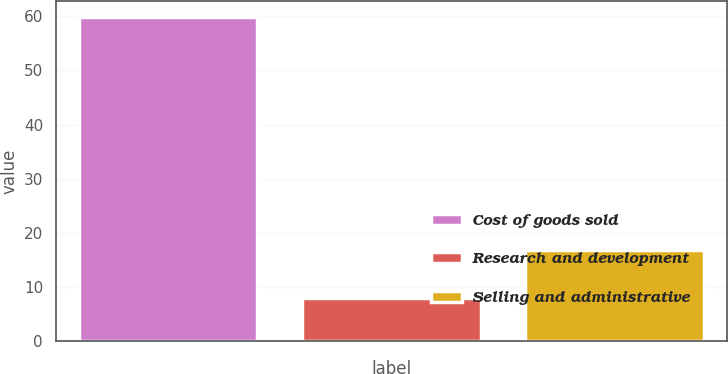<chart> <loc_0><loc_0><loc_500><loc_500><bar_chart><fcel>Cost of goods sold<fcel>Research and development<fcel>Selling and administrative<nl><fcel>59.8<fcel>7.9<fcel>16.8<nl></chart> 